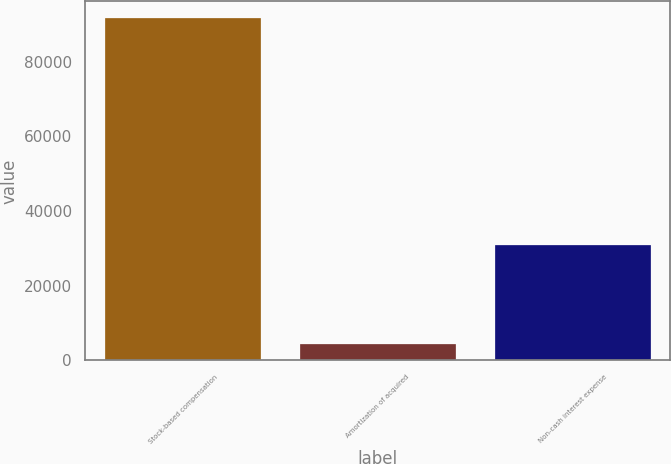Convert chart. <chart><loc_0><loc_0><loc_500><loc_500><bar_chart><fcel>Stock-based compensation<fcel>Amortization of acquired<fcel>Non-cash interest expense<nl><fcel>91606<fcel>4380<fcel>30878<nl></chart> 